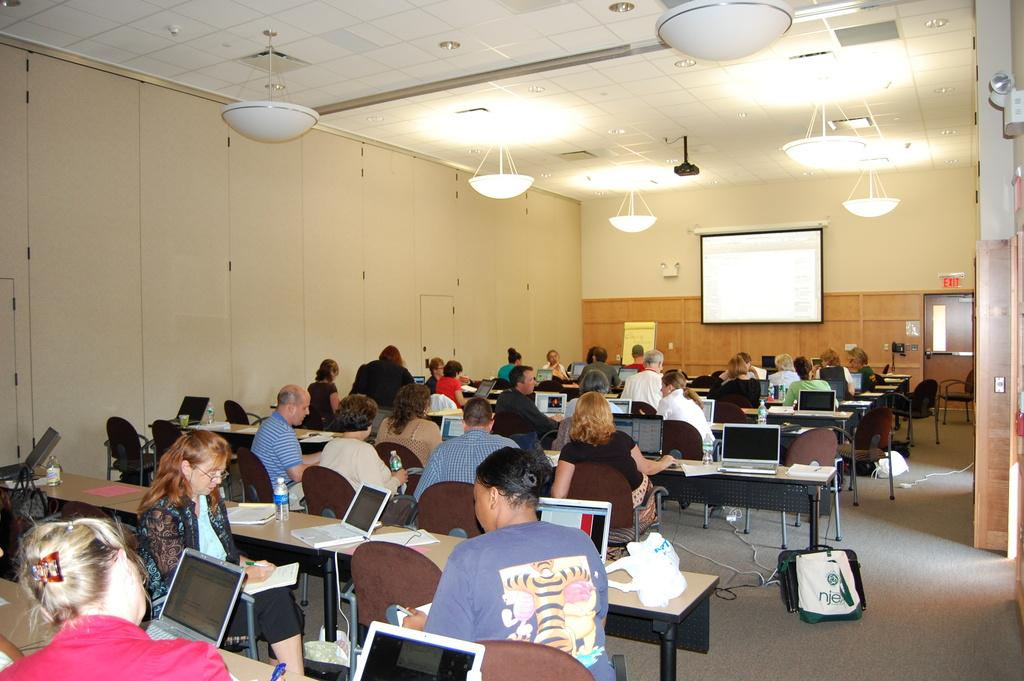What is: What is the main subject of the image? The main subject of the image is a group of people. What are the people doing in the image? The people are seated on chairs in the image. What objects can be seen on the table in the image? There are laptops on a table in the image. What is on the wall in the image? There is a projector screen on the wall in the image. What can be seen in terms of lighting in the image? There are lights visible in the image. What type of fruit is being passed around by the people in the image? There is no fruit present in the image; the people are seated with laptops on a table. What kind of nail is being used by the people in the image? There is no nail visible or mentioned in the image; the people are seated with laptops on a table. 